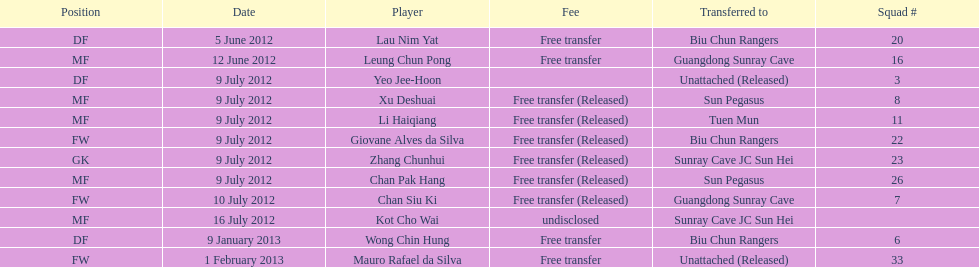What is the overall count of players mentioned? 12. 